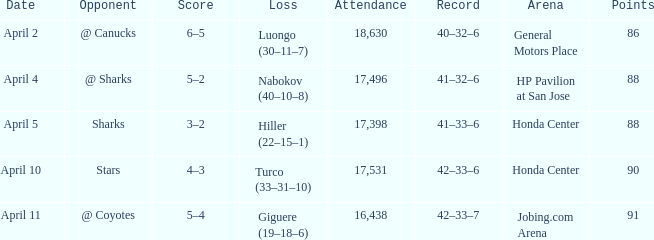In which instances does the attendance have more than 90 points? 16438.0. 